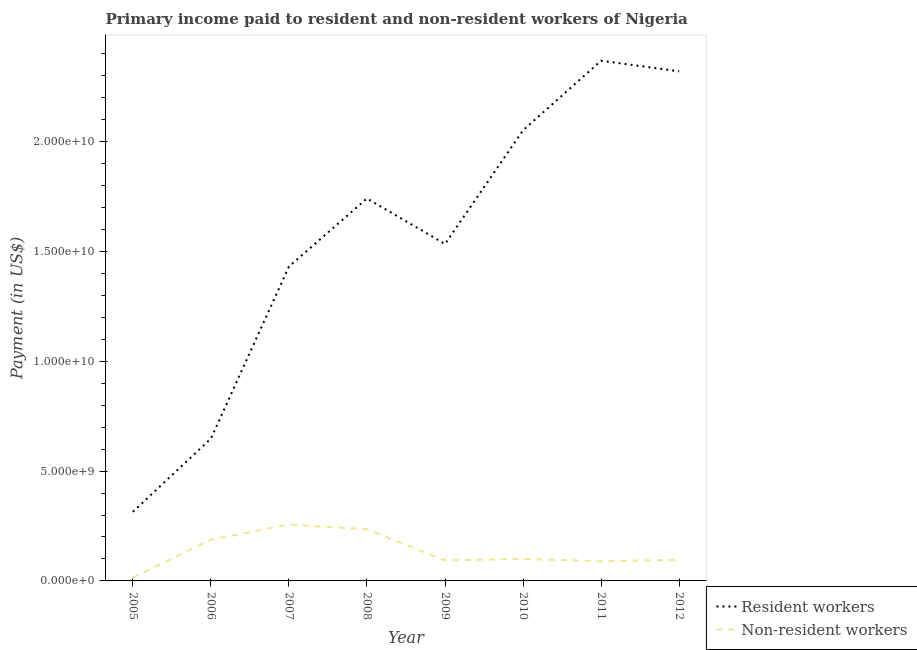How many different coloured lines are there?
Keep it short and to the point. 2. Does the line corresponding to payment made to resident workers intersect with the line corresponding to payment made to non-resident workers?
Give a very brief answer. No. Is the number of lines equal to the number of legend labels?
Ensure brevity in your answer.  Yes. What is the payment made to resident workers in 2009?
Keep it short and to the point. 1.53e+1. Across all years, what is the maximum payment made to non-resident workers?
Keep it short and to the point. 2.56e+09. Across all years, what is the minimum payment made to non-resident workers?
Keep it short and to the point. 1.55e+08. In which year was the payment made to non-resident workers maximum?
Offer a very short reply. 2007. What is the total payment made to resident workers in the graph?
Provide a succinct answer. 1.24e+11. What is the difference between the payment made to resident workers in 2008 and that in 2010?
Keep it short and to the point. -3.10e+09. What is the difference between the payment made to non-resident workers in 2012 and the payment made to resident workers in 2007?
Offer a very short reply. -1.34e+1. What is the average payment made to non-resident workers per year?
Ensure brevity in your answer.  1.34e+09. In the year 2011, what is the difference between the payment made to non-resident workers and payment made to resident workers?
Provide a short and direct response. -2.28e+1. In how many years, is the payment made to non-resident workers greater than 18000000000 US$?
Provide a short and direct response. 0. What is the ratio of the payment made to resident workers in 2006 to that in 2010?
Give a very brief answer. 0.32. Is the payment made to resident workers in 2005 less than that in 2009?
Offer a terse response. Yes. Is the difference between the payment made to resident workers in 2007 and 2008 greater than the difference between the payment made to non-resident workers in 2007 and 2008?
Offer a very short reply. No. What is the difference between the highest and the second highest payment made to resident workers?
Your response must be concise. 4.83e+08. What is the difference between the highest and the lowest payment made to non-resident workers?
Keep it short and to the point. 2.41e+09. In how many years, is the payment made to resident workers greater than the average payment made to resident workers taken over all years?
Make the answer very short. 4. Is the sum of the payment made to non-resident workers in 2007 and 2010 greater than the maximum payment made to resident workers across all years?
Provide a succinct answer. No. Does the payment made to resident workers monotonically increase over the years?
Give a very brief answer. No. Is the payment made to resident workers strictly greater than the payment made to non-resident workers over the years?
Your response must be concise. Yes. How many years are there in the graph?
Ensure brevity in your answer.  8. What is the difference between two consecutive major ticks on the Y-axis?
Offer a terse response. 5.00e+09. Are the values on the major ticks of Y-axis written in scientific E-notation?
Provide a short and direct response. Yes. Where does the legend appear in the graph?
Ensure brevity in your answer.  Bottom right. How many legend labels are there?
Your answer should be very brief. 2. What is the title of the graph?
Your answer should be compact. Primary income paid to resident and non-resident workers of Nigeria. Does "Primary completion rate" appear as one of the legend labels in the graph?
Your response must be concise. No. What is the label or title of the Y-axis?
Offer a very short reply. Payment (in US$). What is the Payment (in US$) in Resident workers in 2005?
Give a very brief answer. 3.15e+09. What is the Payment (in US$) of Non-resident workers in 2005?
Ensure brevity in your answer.  1.55e+08. What is the Payment (in US$) of Resident workers in 2006?
Provide a short and direct response. 6.48e+09. What is the Payment (in US$) of Non-resident workers in 2006?
Keep it short and to the point. 1.88e+09. What is the Payment (in US$) in Resident workers in 2007?
Your answer should be compact. 1.43e+1. What is the Payment (in US$) in Non-resident workers in 2007?
Provide a short and direct response. 2.56e+09. What is the Payment (in US$) of Resident workers in 2008?
Make the answer very short. 1.74e+1. What is the Payment (in US$) of Non-resident workers in 2008?
Your response must be concise. 2.35e+09. What is the Payment (in US$) of Resident workers in 2009?
Offer a terse response. 1.53e+1. What is the Payment (in US$) in Non-resident workers in 2009?
Your response must be concise. 9.35e+08. What is the Payment (in US$) of Resident workers in 2010?
Give a very brief answer. 2.05e+1. What is the Payment (in US$) of Non-resident workers in 2010?
Offer a terse response. 1.00e+09. What is the Payment (in US$) in Resident workers in 2011?
Make the answer very short. 2.37e+1. What is the Payment (in US$) in Non-resident workers in 2011?
Your response must be concise. 8.98e+08. What is the Payment (in US$) of Resident workers in 2012?
Your answer should be very brief. 2.32e+1. What is the Payment (in US$) in Non-resident workers in 2012?
Your answer should be very brief. 9.61e+08. Across all years, what is the maximum Payment (in US$) in Resident workers?
Keep it short and to the point. 2.37e+1. Across all years, what is the maximum Payment (in US$) in Non-resident workers?
Offer a very short reply. 2.56e+09. Across all years, what is the minimum Payment (in US$) in Resident workers?
Offer a very short reply. 3.15e+09. Across all years, what is the minimum Payment (in US$) in Non-resident workers?
Provide a short and direct response. 1.55e+08. What is the total Payment (in US$) in Resident workers in the graph?
Your response must be concise. 1.24e+11. What is the total Payment (in US$) of Non-resident workers in the graph?
Offer a terse response. 1.07e+1. What is the difference between the Payment (in US$) in Resident workers in 2005 and that in 2006?
Give a very brief answer. -3.33e+09. What is the difference between the Payment (in US$) in Non-resident workers in 2005 and that in 2006?
Provide a short and direct response. -1.72e+09. What is the difference between the Payment (in US$) of Resident workers in 2005 and that in 2007?
Provide a short and direct response. -1.12e+1. What is the difference between the Payment (in US$) in Non-resident workers in 2005 and that in 2007?
Your response must be concise. -2.41e+09. What is the difference between the Payment (in US$) of Resident workers in 2005 and that in 2008?
Offer a very short reply. -1.43e+1. What is the difference between the Payment (in US$) of Non-resident workers in 2005 and that in 2008?
Make the answer very short. -2.20e+09. What is the difference between the Payment (in US$) in Resident workers in 2005 and that in 2009?
Your response must be concise. -1.22e+1. What is the difference between the Payment (in US$) of Non-resident workers in 2005 and that in 2009?
Give a very brief answer. -7.80e+08. What is the difference between the Payment (in US$) of Resident workers in 2005 and that in 2010?
Ensure brevity in your answer.  -1.74e+1. What is the difference between the Payment (in US$) of Non-resident workers in 2005 and that in 2010?
Make the answer very short. -8.46e+08. What is the difference between the Payment (in US$) in Resident workers in 2005 and that in 2011?
Give a very brief answer. -2.05e+1. What is the difference between the Payment (in US$) in Non-resident workers in 2005 and that in 2011?
Provide a short and direct response. -7.42e+08. What is the difference between the Payment (in US$) of Resident workers in 2005 and that in 2012?
Offer a very short reply. -2.01e+1. What is the difference between the Payment (in US$) of Non-resident workers in 2005 and that in 2012?
Provide a succinct answer. -8.06e+08. What is the difference between the Payment (in US$) in Resident workers in 2006 and that in 2007?
Your response must be concise. -7.83e+09. What is the difference between the Payment (in US$) in Non-resident workers in 2006 and that in 2007?
Offer a terse response. -6.89e+08. What is the difference between the Payment (in US$) in Resident workers in 2006 and that in 2008?
Ensure brevity in your answer.  -1.09e+1. What is the difference between the Payment (in US$) in Non-resident workers in 2006 and that in 2008?
Make the answer very short. -4.77e+08. What is the difference between the Payment (in US$) in Resident workers in 2006 and that in 2009?
Your response must be concise. -8.86e+09. What is the difference between the Payment (in US$) of Non-resident workers in 2006 and that in 2009?
Offer a terse response. 9.40e+08. What is the difference between the Payment (in US$) of Resident workers in 2006 and that in 2010?
Your response must be concise. -1.40e+1. What is the difference between the Payment (in US$) of Non-resident workers in 2006 and that in 2010?
Make the answer very short. 8.74e+08. What is the difference between the Payment (in US$) in Resident workers in 2006 and that in 2011?
Give a very brief answer. -1.72e+1. What is the difference between the Payment (in US$) in Non-resident workers in 2006 and that in 2011?
Your answer should be very brief. 9.78e+08. What is the difference between the Payment (in US$) in Resident workers in 2006 and that in 2012?
Ensure brevity in your answer.  -1.67e+1. What is the difference between the Payment (in US$) in Non-resident workers in 2006 and that in 2012?
Offer a very short reply. 9.14e+08. What is the difference between the Payment (in US$) in Resident workers in 2007 and that in 2008?
Your answer should be compact. -3.10e+09. What is the difference between the Payment (in US$) of Non-resident workers in 2007 and that in 2008?
Your response must be concise. 2.12e+08. What is the difference between the Payment (in US$) in Resident workers in 2007 and that in 2009?
Your answer should be very brief. -1.03e+09. What is the difference between the Payment (in US$) in Non-resident workers in 2007 and that in 2009?
Provide a short and direct response. 1.63e+09. What is the difference between the Payment (in US$) of Resident workers in 2007 and that in 2010?
Your response must be concise. -6.20e+09. What is the difference between the Payment (in US$) in Non-resident workers in 2007 and that in 2010?
Offer a terse response. 1.56e+09. What is the difference between the Payment (in US$) in Resident workers in 2007 and that in 2011?
Offer a terse response. -9.37e+09. What is the difference between the Payment (in US$) of Non-resident workers in 2007 and that in 2011?
Provide a succinct answer. 1.67e+09. What is the difference between the Payment (in US$) in Resident workers in 2007 and that in 2012?
Your answer should be very brief. -8.89e+09. What is the difference between the Payment (in US$) in Non-resident workers in 2007 and that in 2012?
Make the answer very short. 1.60e+09. What is the difference between the Payment (in US$) in Resident workers in 2008 and that in 2009?
Provide a short and direct response. 2.07e+09. What is the difference between the Payment (in US$) in Non-resident workers in 2008 and that in 2009?
Offer a very short reply. 1.42e+09. What is the difference between the Payment (in US$) of Resident workers in 2008 and that in 2010?
Offer a terse response. -3.10e+09. What is the difference between the Payment (in US$) of Non-resident workers in 2008 and that in 2010?
Your response must be concise. 1.35e+09. What is the difference between the Payment (in US$) in Resident workers in 2008 and that in 2011?
Your response must be concise. -6.27e+09. What is the difference between the Payment (in US$) in Non-resident workers in 2008 and that in 2011?
Provide a succinct answer. 1.45e+09. What is the difference between the Payment (in US$) of Resident workers in 2008 and that in 2012?
Make the answer very short. -5.79e+09. What is the difference between the Payment (in US$) of Non-resident workers in 2008 and that in 2012?
Ensure brevity in your answer.  1.39e+09. What is the difference between the Payment (in US$) in Resident workers in 2009 and that in 2010?
Your answer should be very brief. -5.17e+09. What is the difference between the Payment (in US$) of Non-resident workers in 2009 and that in 2010?
Keep it short and to the point. -6.62e+07. What is the difference between the Payment (in US$) in Resident workers in 2009 and that in 2011?
Make the answer very short. -8.34e+09. What is the difference between the Payment (in US$) in Non-resident workers in 2009 and that in 2011?
Keep it short and to the point. 3.77e+07. What is the difference between the Payment (in US$) of Resident workers in 2009 and that in 2012?
Your answer should be compact. -7.86e+09. What is the difference between the Payment (in US$) in Non-resident workers in 2009 and that in 2012?
Keep it short and to the point. -2.55e+07. What is the difference between the Payment (in US$) in Resident workers in 2010 and that in 2011?
Keep it short and to the point. -3.17e+09. What is the difference between the Payment (in US$) of Non-resident workers in 2010 and that in 2011?
Your answer should be very brief. 1.04e+08. What is the difference between the Payment (in US$) in Resident workers in 2010 and that in 2012?
Give a very brief answer. -2.69e+09. What is the difference between the Payment (in US$) in Non-resident workers in 2010 and that in 2012?
Provide a succinct answer. 4.07e+07. What is the difference between the Payment (in US$) of Resident workers in 2011 and that in 2012?
Make the answer very short. 4.83e+08. What is the difference between the Payment (in US$) in Non-resident workers in 2011 and that in 2012?
Give a very brief answer. -6.31e+07. What is the difference between the Payment (in US$) of Resident workers in 2005 and the Payment (in US$) of Non-resident workers in 2006?
Offer a very short reply. 1.27e+09. What is the difference between the Payment (in US$) of Resident workers in 2005 and the Payment (in US$) of Non-resident workers in 2007?
Your response must be concise. 5.82e+08. What is the difference between the Payment (in US$) of Resident workers in 2005 and the Payment (in US$) of Non-resident workers in 2008?
Your answer should be very brief. 7.94e+08. What is the difference between the Payment (in US$) in Resident workers in 2005 and the Payment (in US$) in Non-resident workers in 2009?
Keep it short and to the point. 2.21e+09. What is the difference between the Payment (in US$) in Resident workers in 2005 and the Payment (in US$) in Non-resident workers in 2010?
Your response must be concise. 2.14e+09. What is the difference between the Payment (in US$) in Resident workers in 2005 and the Payment (in US$) in Non-resident workers in 2011?
Provide a short and direct response. 2.25e+09. What is the difference between the Payment (in US$) in Resident workers in 2005 and the Payment (in US$) in Non-resident workers in 2012?
Provide a short and direct response. 2.19e+09. What is the difference between the Payment (in US$) of Resident workers in 2006 and the Payment (in US$) of Non-resident workers in 2007?
Offer a terse response. 3.91e+09. What is the difference between the Payment (in US$) in Resident workers in 2006 and the Payment (in US$) in Non-resident workers in 2008?
Provide a short and direct response. 4.12e+09. What is the difference between the Payment (in US$) in Resident workers in 2006 and the Payment (in US$) in Non-resident workers in 2009?
Offer a very short reply. 5.54e+09. What is the difference between the Payment (in US$) of Resident workers in 2006 and the Payment (in US$) of Non-resident workers in 2010?
Give a very brief answer. 5.48e+09. What is the difference between the Payment (in US$) of Resident workers in 2006 and the Payment (in US$) of Non-resident workers in 2011?
Provide a succinct answer. 5.58e+09. What is the difference between the Payment (in US$) of Resident workers in 2006 and the Payment (in US$) of Non-resident workers in 2012?
Keep it short and to the point. 5.52e+09. What is the difference between the Payment (in US$) of Resident workers in 2007 and the Payment (in US$) of Non-resident workers in 2008?
Provide a short and direct response. 1.20e+1. What is the difference between the Payment (in US$) in Resident workers in 2007 and the Payment (in US$) in Non-resident workers in 2009?
Keep it short and to the point. 1.34e+1. What is the difference between the Payment (in US$) in Resident workers in 2007 and the Payment (in US$) in Non-resident workers in 2010?
Offer a very short reply. 1.33e+1. What is the difference between the Payment (in US$) of Resident workers in 2007 and the Payment (in US$) of Non-resident workers in 2011?
Keep it short and to the point. 1.34e+1. What is the difference between the Payment (in US$) of Resident workers in 2007 and the Payment (in US$) of Non-resident workers in 2012?
Your response must be concise. 1.34e+1. What is the difference between the Payment (in US$) in Resident workers in 2008 and the Payment (in US$) in Non-resident workers in 2009?
Give a very brief answer. 1.65e+1. What is the difference between the Payment (in US$) of Resident workers in 2008 and the Payment (in US$) of Non-resident workers in 2010?
Offer a very short reply. 1.64e+1. What is the difference between the Payment (in US$) of Resident workers in 2008 and the Payment (in US$) of Non-resident workers in 2011?
Make the answer very short. 1.65e+1. What is the difference between the Payment (in US$) of Resident workers in 2008 and the Payment (in US$) of Non-resident workers in 2012?
Your answer should be compact. 1.65e+1. What is the difference between the Payment (in US$) of Resident workers in 2009 and the Payment (in US$) of Non-resident workers in 2010?
Give a very brief answer. 1.43e+1. What is the difference between the Payment (in US$) in Resident workers in 2009 and the Payment (in US$) in Non-resident workers in 2011?
Give a very brief answer. 1.44e+1. What is the difference between the Payment (in US$) of Resident workers in 2009 and the Payment (in US$) of Non-resident workers in 2012?
Your response must be concise. 1.44e+1. What is the difference between the Payment (in US$) in Resident workers in 2010 and the Payment (in US$) in Non-resident workers in 2011?
Your response must be concise. 1.96e+1. What is the difference between the Payment (in US$) in Resident workers in 2010 and the Payment (in US$) in Non-resident workers in 2012?
Provide a succinct answer. 1.96e+1. What is the difference between the Payment (in US$) of Resident workers in 2011 and the Payment (in US$) of Non-resident workers in 2012?
Make the answer very short. 2.27e+1. What is the average Payment (in US$) in Resident workers per year?
Your answer should be very brief. 1.55e+1. What is the average Payment (in US$) in Non-resident workers per year?
Give a very brief answer. 1.34e+09. In the year 2005, what is the difference between the Payment (in US$) in Resident workers and Payment (in US$) in Non-resident workers?
Ensure brevity in your answer.  2.99e+09. In the year 2006, what is the difference between the Payment (in US$) in Resident workers and Payment (in US$) in Non-resident workers?
Your answer should be very brief. 4.60e+09. In the year 2007, what is the difference between the Payment (in US$) of Resident workers and Payment (in US$) of Non-resident workers?
Give a very brief answer. 1.17e+1. In the year 2008, what is the difference between the Payment (in US$) of Resident workers and Payment (in US$) of Non-resident workers?
Offer a very short reply. 1.51e+1. In the year 2009, what is the difference between the Payment (in US$) in Resident workers and Payment (in US$) in Non-resident workers?
Keep it short and to the point. 1.44e+1. In the year 2010, what is the difference between the Payment (in US$) in Resident workers and Payment (in US$) in Non-resident workers?
Keep it short and to the point. 1.95e+1. In the year 2011, what is the difference between the Payment (in US$) of Resident workers and Payment (in US$) of Non-resident workers?
Give a very brief answer. 2.28e+1. In the year 2012, what is the difference between the Payment (in US$) in Resident workers and Payment (in US$) in Non-resident workers?
Keep it short and to the point. 2.22e+1. What is the ratio of the Payment (in US$) in Resident workers in 2005 to that in 2006?
Offer a very short reply. 0.49. What is the ratio of the Payment (in US$) of Non-resident workers in 2005 to that in 2006?
Your response must be concise. 0.08. What is the ratio of the Payment (in US$) of Resident workers in 2005 to that in 2007?
Offer a very short reply. 0.22. What is the ratio of the Payment (in US$) of Non-resident workers in 2005 to that in 2007?
Your answer should be very brief. 0.06. What is the ratio of the Payment (in US$) of Resident workers in 2005 to that in 2008?
Your response must be concise. 0.18. What is the ratio of the Payment (in US$) in Non-resident workers in 2005 to that in 2008?
Provide a short and direct response. 0.07. What is the ratio of the Payment (in US$) in Resident workers in 2005 to that in 2009?
Ensure brevity in your answer.  0.21. What is the ratio of the Payment (in US$) in Non-resident workers in 2005 to that in 2009?
Keep it short and to the point. 0.17. What is the ratio of the Payment (in US$) in Resident workers in 2005 to that in 2010?
Your answer should be very brief. 0.15. What is the ratio of the Payment (in US$) of Non-resident workers in 2005 to that in 2010?
Offer a terse response. 0.15. What is the ratio of the Payment (in US$) in Resident workers in 2005 to that in 2011?
Keep it short and to the point. 0.13. What is the ratio of the Payment (in US$) in Non-resident workers in 2005 to that in 2011?
Ensure brevity in your answer.  0.17. What is the ratio of the Payment (in US$) of Resident workers in 2005 to that in 2012?
Keep it short and to the point. 0.14. What is the ratio of the Payment (in US$) of Non-resident workers in 2005 to that in 2012?
Provide a short and direct response. 0.16. What is the ratio of the Payment (in US$) in Resident workers in 2006 to that in 2007?
Your response must be concise. 0.45. What is the ratio of the Payment (in US$) of Non-resident workers in 2006 to that in 2007?
Offer a terse response. 0.73. What is the ratio of the Payment (in US$) in Resident workers in 2006 to that in 2008?
Offer a terse response. 0.37. What is the ratio of the Payment (in US$) of Non-resident workers in 2006 to that in 2008?
Provide a succinct answer. 0.8. What is the ratio of the Payment (in US$) of Resident workers in 2006 to that in 2009?
Offer a terse response. 0.42. What is the ratio of the Payment (in US$) in Non-resident workers in 2006 to that in 2009?
Provide a short and direct response. 2. What is the ratio of the Payment (in US$) of Resident workers in 2006 to that in 2010?
Ensure brevity in your answer.  0.32. What is the ratio of the Payment (in US$) in Non-resident workers in 2006 to that in 2010?
Offer a terse response. 1.87. What is the ratio of the Payment (in US$) in Resident workers in 2006 to that in 2011?
Keep it short and to the point. 0.27. What is the ratio of the Payment (in US$) in Non-resident workers in 2006 to that in 2011?
Ensure brevity in your answer.  2.09. What is the ratio of the Payment (in US$) of Resident workers in 2006 to that in 2012?
Give a very brief answer. 0.28. What is the ratio of the Payment (in US$) in Non-resident workers in 2006 to that in 2012?
Your answer should be compact. 1.95. What is the ratio of the Payment (in US$) of Resident workers in 2007 to that in 2008?
Offer a terse response. 0.82. What is the ratio of the Payment (in US$) in Non-resident workers in 2007 to that in 2008?
Offer a terse response. 1.09. What is the ratio of the Payment (in US$) in Resident workers in 2007 to that in 2009?
Provide a short and direct response. 0.93. What is the ratio of the Payment (in US$) of Non-resident workers in 2007 to that in 2009?
Your response must be concise. 2.74. What is the ratio of the Payment (in US$) in Resident workers in 2007 to that in 2010?
Offer a very short reply. 0.7. What is the ratio of the Payment (in US$) of Non-resident workers in 2007 to that in 2010?
Provide a short and direct response. 2.56. What is the ratio of the Payment (in US$) of Resident workers in 2007 to that in 2011?
Ensure brevity in your answer.  0.6. What is the ratio of the Payment (in US$) in Non-resident workers in 2007 to that in 2011?
Your answer should be very brief. 2.86. What is the ratio of the Payment (in US$) of Resident workers in 2007 to that in 2012?
Offer a very short reply. 0.62. What is the ratio of the Payment (in US$) of Non-resident workers in 2007 to that in 2012?
Your response must be concise. 2.67. What is the ratio of the Payment (in US$) in Resident workers in 2008 to that in 2009?
Your answer should be compact. 1.14. What is the ratio of the Payment (in US$) in Non-resident workers in 2008 to that in 2009?
Give a very brief answer. 2.51. What is the ratio of the Payment (in US$) in Resident workers in 2008 to that in 2010?
Provide a short and direct response. 0.85. What is the ratio of the Payment (in US$) in Non-resident workers in 2008 to that in 2010?
Offer a terse response. 2.35. What is the ratio of the Payment (in US$) of Resident workers in 2008 to that in 2011?
Offer a terse response. 0.74. What is the ratio of the Payment (in US$) in Non-resident workers in 2008 to that in 2011?
Ensure brevity in your answer.  2.62. What is the ratio of the Payment (in US$) in Resident workers in 2008 to that in 2012?
Offer a terse response. 0.75. What is the ratio of the Payment (in US$) in Non-resident workers in 2008 to that in 2012?
Your response must be concise. 2.45. What is the ratio of the Payment (in US$) in Resident workers in 2009 to that in 2010?
Offer a terse response. 0.75. What is the ratio of the Payment (in US$) of Non-resident workers in 2009 to that in 2010?
Give a very brief answer. 0.93. What is the ratio of the Payment (in US$) of Resident workers in 2009 to that in 2011?
Your answer should be very brief. 0.65. What is the ratio of the Payment (in US$) in Non-resident workers in 2009 to that in 2011?
Your answer should be very brief. 1.04. What is the ratio of the Payment (in US$) in Resident workers in 2009 to that in 2012?
Provide a succinct answer. 0.66. What is the ratio of the Payment (in US$) of Non-resident workers in 2009 to that in 2012?
Give a very brief answer. 0.97. What is the ratio of the Payment (in US$) in Resident workers in 2010 to that in 2011?
Make the answer very short. 0.87. What is the ratio of the Payment (in US$) in Non-resident workers in 2010 to that in 2011?
Ensure brevity in your answer.  1.12. What is the ratio of the Payment (in US$) of Resident workers in 2010 to that in 2012?
Your answer should be compact. 0.88. What is the ratio of the Payment (in US$) in Non-resident workers in 2010 to that in 2012?
Keep it short and to the point. 1.04. What is the ratio of the Payment (in US$) of Resident workers in 2011 to that in 2012?
Provide a short and direct response. 1.02. What is the ratio of the Payment (in US$) in Non-resident workers in 2011 to that in 2012?
Give a very brief answer. 0.93. What is the difference between the highest and the second highest Payment (in US$) in Resident workers?
Give a very brief answer. 4.83e+08. What is the difference between the highest and the second highest Payment (in US$) of Non-resident workers?
Give a very brief answer. 2.12e+08. What is the difference between the highest and the lowest Payment (in US$) in Resident workers?
Provide a succinct answer. 2.05e+1. What is the difference between the highest and the lowest Payment (in US$) in Non-resident workers?
Your answer should be compact. 2.41e+09. 